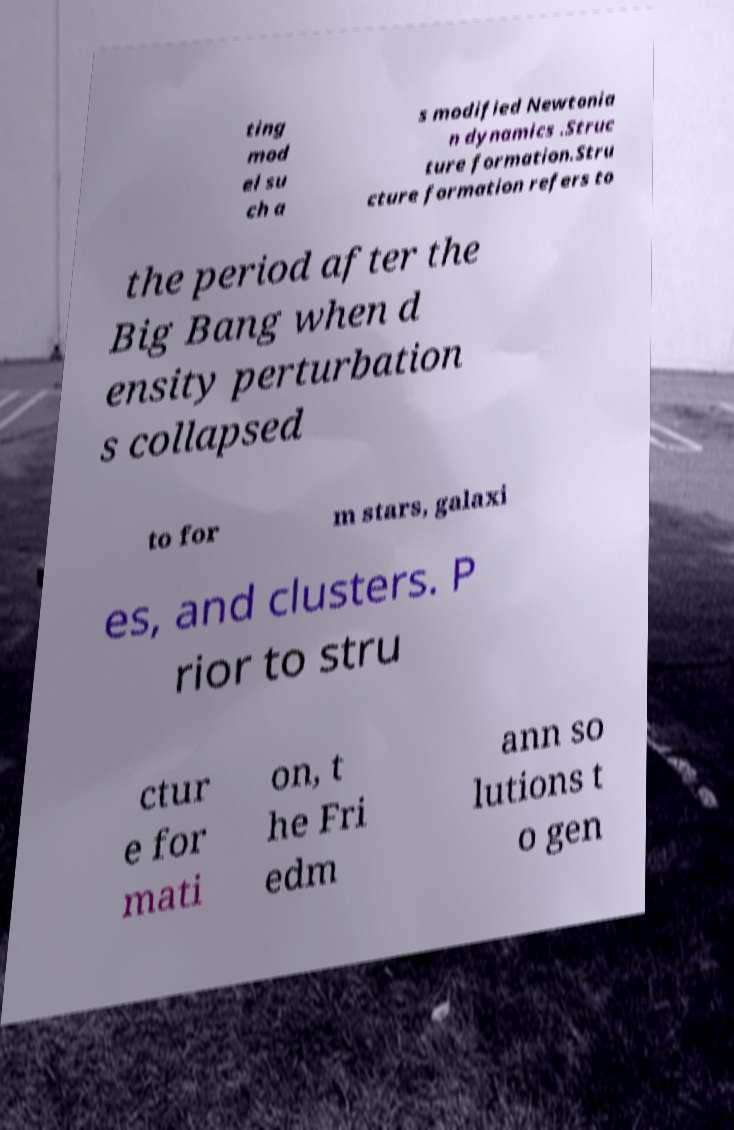I need the written content from this picture converted into text. Can you do that? ting mod el su ch a s modified Newtonia n dynamics .Struc ture formation.Stru cture formation refers to the period after the Big Bang when d ensity perturbation s collapsed to for m stars, galaxi es, and clusters. P rior to stru ctur e for mati on, t he Fri edm ann so lutions t o gen 